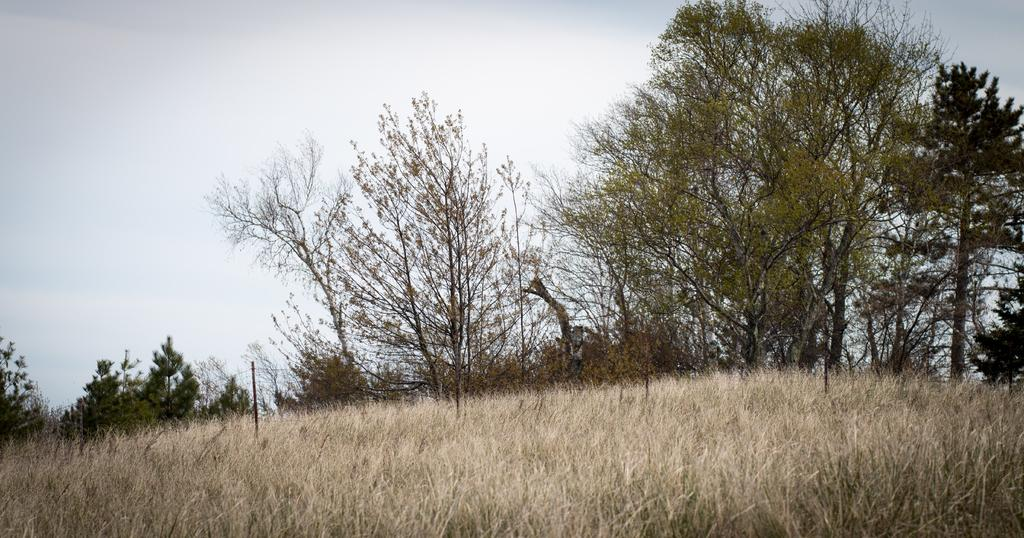What type of vegetation is present in the image? There is dry grass in the image. What structure can be seen in the image? There is a pole in the image. What other natural elements are visible in the image? There are trees in the image. What is visible at the top of the image? The sky is visible at the top of the image. Can you tell me how many frogs are sitting on the pole in the image? There are no frogs present in the image; it features dry grass, a pole, trees, and the sky. What type of quartz can be seen in the image? There is no quartz present in the image. 